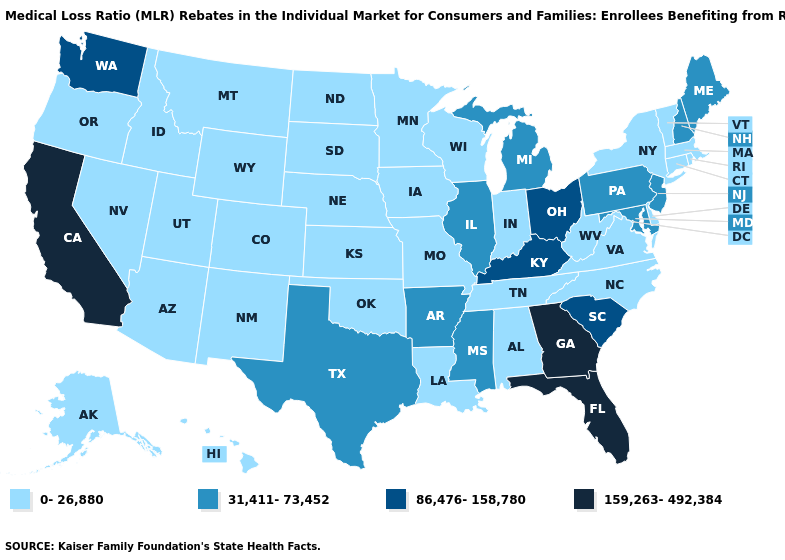Which states have the lowest value in the USA?
Be succinct. Alabama, Alaska, Arizona, Colorado, Connecticut, Delaware, Hawaii, Idaho, Indiana, Iowa, Kansas, Louisiana, Massachusetts, Minnesota, Missouri, Montana, Nebraska, Nevada, New Mexico, New York, North Carolina, North Dakota, Oklahoma, Oregon, Rhode Island, South Dakota, Tennessee, Utah, Vermont, Virginia, West Virginia, Wisconsin, Wyoming. Name the states that have a value in the range 31,411-73,452?
Give a very brief answer. Arkansas, Illinois, Maine, Maryland, Michigan, Mississippi, New Hampshire, New Jersey, Pennsylvania, Texas. Does Florida have the highest value in the USA?
Keep it brief. Yes. What is the highest value in the USA?
Keep it brief. 159,263-492,384. What is the lowest value in the Northeast?
Concise answer only. 0-26,880. Among the states that border North Carolina , does South Carolina have the highest value?
Concise answer only. No. What is the value of Indiana?
Give a very brief answer. 0-26,880. What is the value of South Carolina?
Quick response, please. 86,476-158,780. What is the value of Maine?
Concise answer only. 31,411-73,452. Does New Jersey have a higher value than Idaho?
Keep it brief. Yes. What is the value of West Virginia?
Concise answer only. 0-26,880. Is the legend a continuous bar?
Quick response, please. No. What is the highest value in states that border California?
Answer briefly. 0-26,880. Name the states that have a value in the range 159,263-492,384?
Short answer required. California, Florida, Georgia. Name the states that have a value in the range 159,263-492,384?
Write a very short answer. California, Florida, Georgia. 